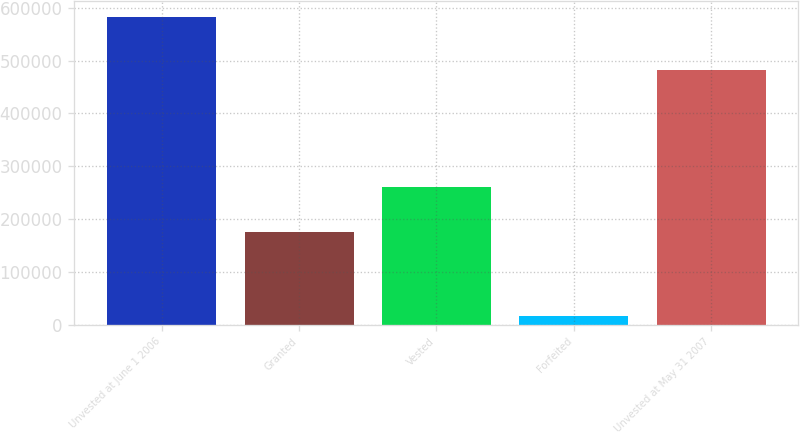Convert chart to OTSL. <chart><loc_0><loc_0><loc_500><loc_500><bar_chart><fcel>Unvested at June 1 2006<fcel>Granted<fcel>Vested<fcel>Forfeited<fcel>Unvested at May 31 2007<nl><fcel>583106<fcel>175005<fcel>260821<fcel>15943<fcel>481347<nl></chart> 